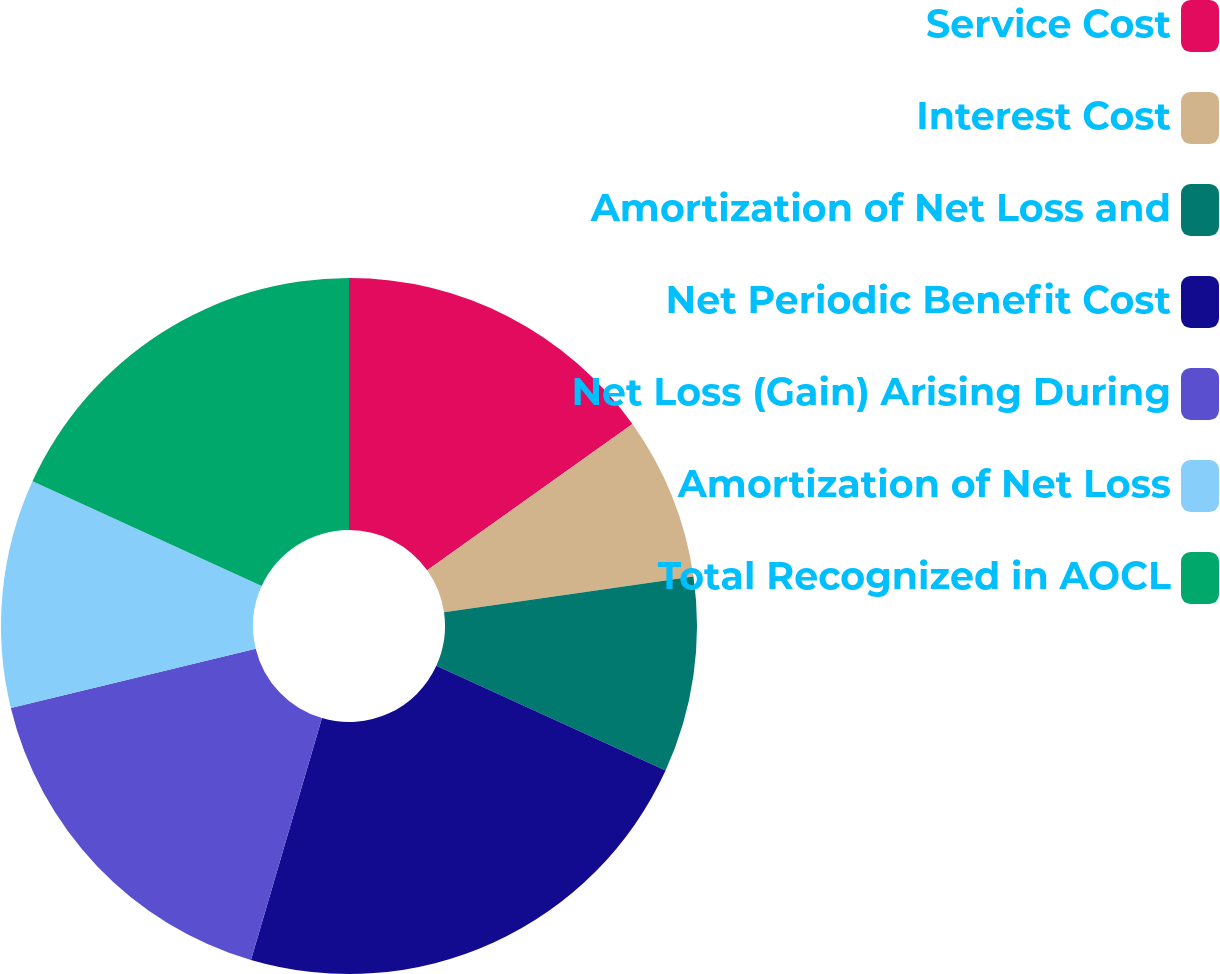Convert chart. <chart><loc_0><loc_0><loc_500><loc_500><pie_chart><fcel>Service Cost<fcel>Interest Cost<fcel>Amortization of Net Loss and<fcel>Net Periodic Benefit Cost<fcel>Net Loss (Gain) Arising During<fcel>Amortization of Net Loss<fcel>Total Recognized in AOCL<nl><fcel>15.15%<fcel>7.58%<fcel>9.09%<fcel>22.73%<fcel>16.67%<fcel>10.61%<fcel>18.18%<nl></chart> 